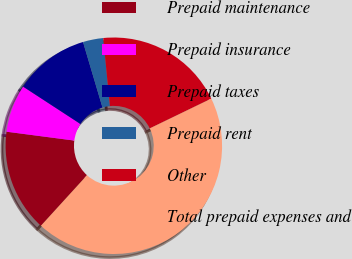Convert chart to OTSL. <chart><loc_0><loc_0><loc_500><loc_500><pie_chart><fcel>Prepaid maintenance<fcel>Prepaid insurance<fcel>Prepaid taxes<fcel>Prepaid rent<fcel>Other<fcel>Total prepaid expenses and<nl><fcel>15.3%<fcel>7.12%<fcel>11.21%<fcel>3.03%<fcel>19.39%<fcel>43.94%<nl></chart> 